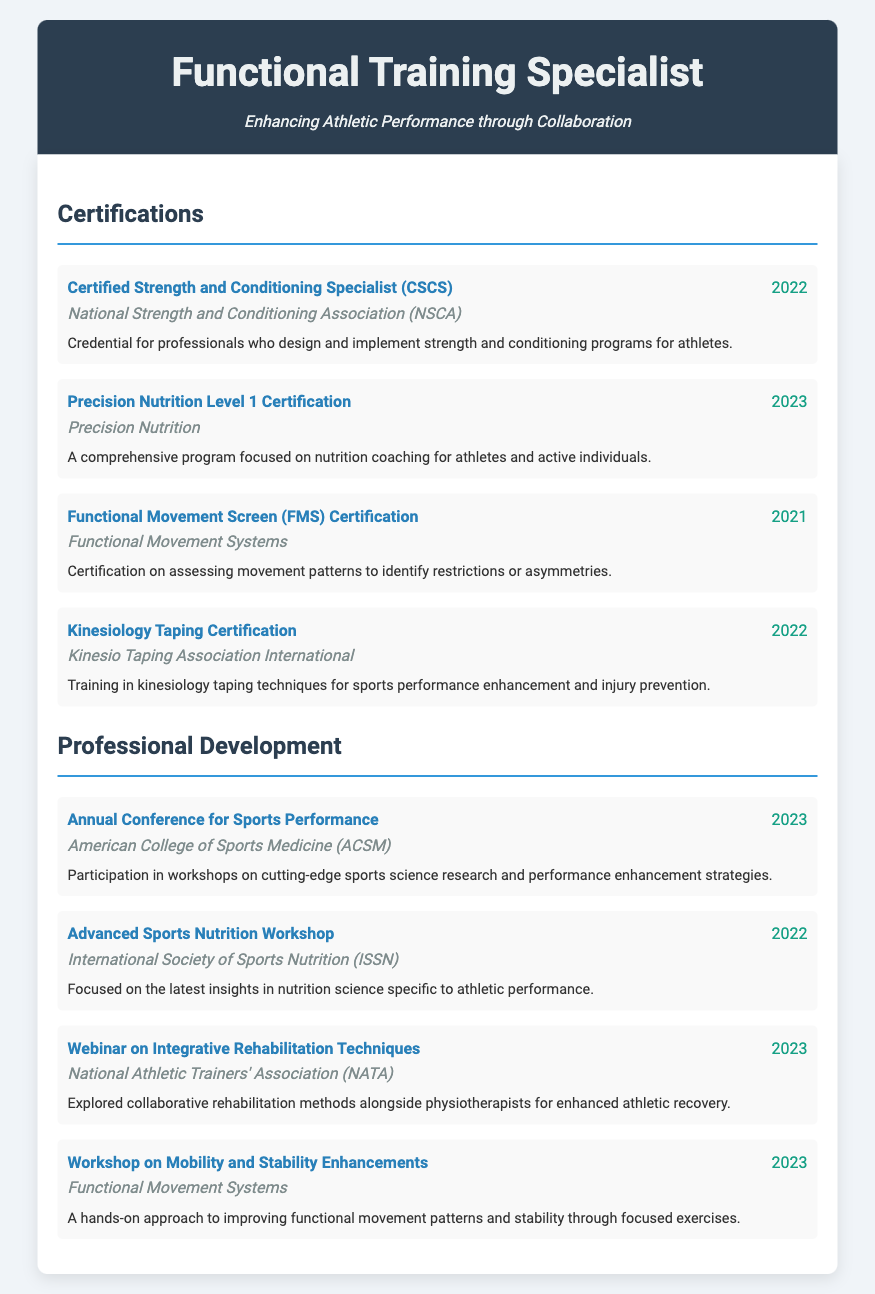what is the name of the certification earned in 2022? The name of the certification earned in 2022 is "Certified Strength and Conditioning Specialist (CSCS)" and "Kinesiology Taping Certification".
Answer: Certified Strength and Conditioning Specialist (CSCS), Kinesiology Taping Certification who issued the Precision Nutrition Level 1 Certification? The organization that issued the Precision Nutrition Level 1 Certification is Precision Nutrition.
Answer: Precision Nutrition what year was the Functional Movement Screen (FMS) Certification obtained? The year the Functional Movement Screen (FMS) Certification was obtained is 2021.
Answer: 2021 which professional development event took place in 2023? The professional development events that took place in 2023 include "Annual Conference for Sports Performance" and "Webinar on Integrative Rehabilitation Techniques".
Answer: Annual Conference for Sports Performance, Webinar on Integrative Rehabilitation Techniques what is the focus of the Advanced Sports Nutrition Workshop? The focus of the Advanced Sports Nutrition Workshop is on the latest insights in nutrition science specific to athletic performance.
Answer: Latest insights in nutrition science specific to athletic performance how many certifications are listed in the document? There are four certifications listed in the document.
Answer: Four which certification is related to assessing movement patterns? The certification related to assessing movement patterns is "Functional Movement Screen (FMS) Certification".
Answer: Functional Movement Screen (FMS) Certification what is the main theme of the workshop conducted by Functional Movement Systems in 2023? The main theme of the workshop conducted by Functional Movement Systems in 2023 is improving functional movement patterns and stability.
Answer: Improving functional movement patterns and stability 